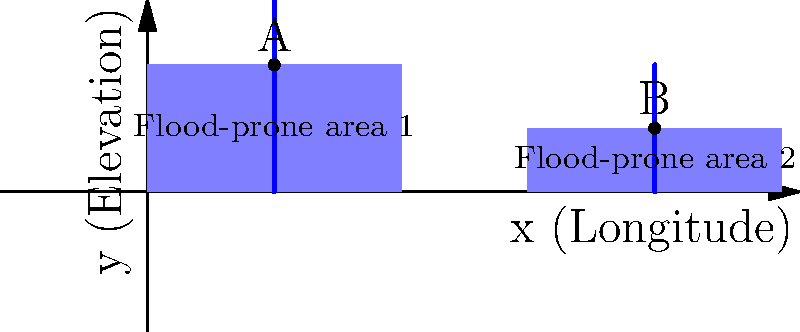In the coordinate system above, two flood-prone areas are mapped along with proposed drainage systems. Point A is located at (2, 2) and point B is at (8, 1). If the x-axis represents longitude and the y-axis represents elevation, calculate the slope of the line connecting points A and B. How might this information be useful in designing a resilient drainage system? To solve this problem, we'll follow these steps:

1) Recall the slope formula: $m = \frac{y_2 - y_1}{x_2 - x_1}$

2) Identify the coordinates:
   Point A: $(x_1, y_1) = (2, 2)$
   Point B: $(x_2, y_2) = (8, 1)$

3) Plug these values into the slope formula:

   $m = \frac{1 - 2}{8 - 2} = \frac{-1}{6} = -\frac{1}{6}$

4) Simplify: The slope is $-\frac{1}{6}$ or approximately -0.167.

This information is useful in designing a resilient drainage system for several reasons:

a) The negative slope indicates that the elevation decreases from point A to point B, which is favorable for gravity-driven water flow.

b) The magnitude of the slope (1/6) provides information about the rate of elevation change, which is crucial for determining the flow rate and capacity requirements of the drainage system.

c) Understanding the slope between different points in flood-prone areas helps in planning the most efficient routes for drainage systems, ensuring that water is directed away from vulnerable areas.

d) The slope information can be used to calculate the potential energy of water flow, which is essential in designing energy dissipation structures to prevent erosion at discharge points.

e) By analyzing slopes across the entire mapped area, engineers can identify natural drainage patterns and integrate them into the design, creating a more resilient and nature-based solution.
Answer: $-\frac{1}{6}$ 